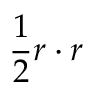Convert formula to latex. <formula><loc_0><loc_0><loc_500><loc_500>\frac { 1 } { 2 } r \cdot r</formula> 